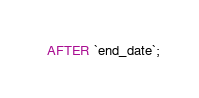<code> <loc_0><loc_0><loc_500><loc_500><_SQL_>  AFTER `end_date`;
</code> 